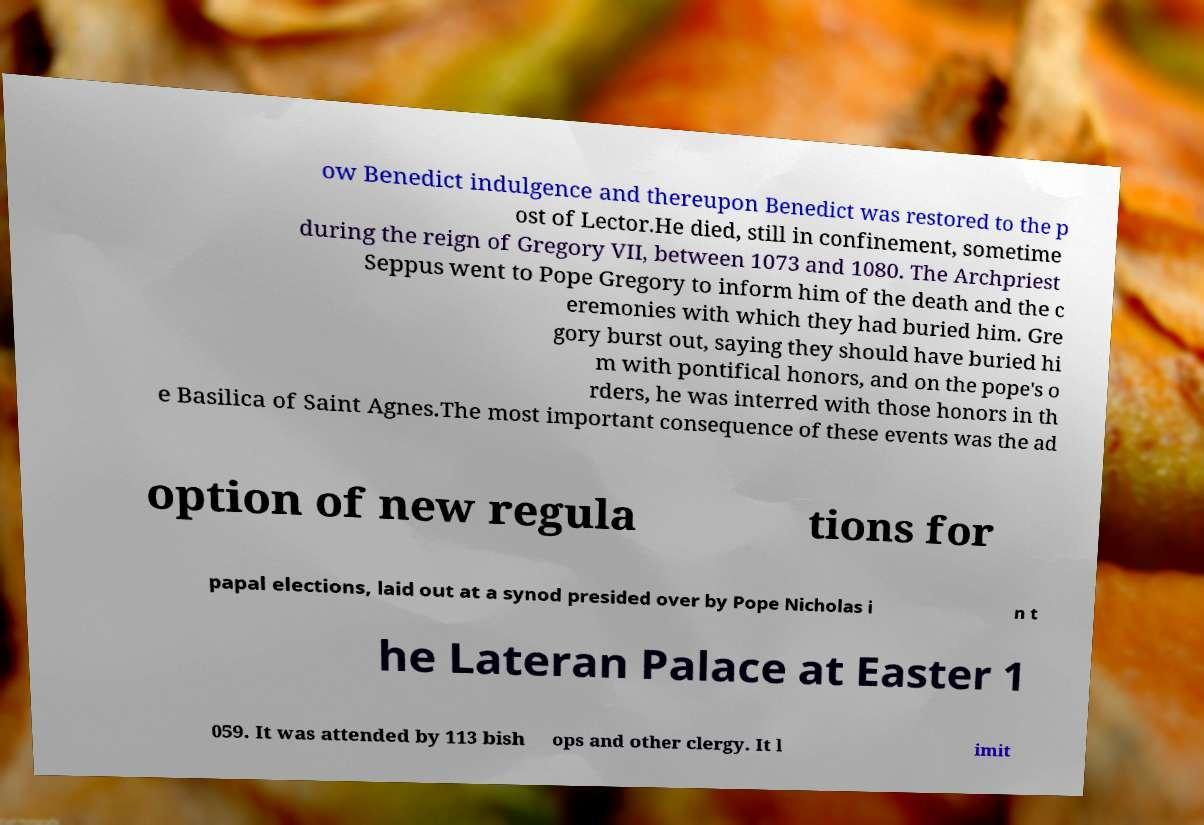What messages or text are displayed in this image? I need them in a readable, typed format. ow Benedict indulgence and thereupon Benedict was restored to the p ost of Lector.He died, still in confinement, sometime during the reign of Gregory VII, between 1073 and 1080. The Archpriest Seppus went to Pope Gregory to inform him of the death and the c eremonies with which they had buried him. Gre gory burst out, saying they should have buried hi m with pontifical honors, and on the pope's o rders, he was interred with those honors in th e Basilica of Saint Agnes.The most important consequence of these events was the ad option of new regula tions for papal elections, laid out at a synod presided over by Pope Nicholas i n t he Lateran Palace at Easter 1 059. It was attended by 113 bish ops and other clergy. It l imit 